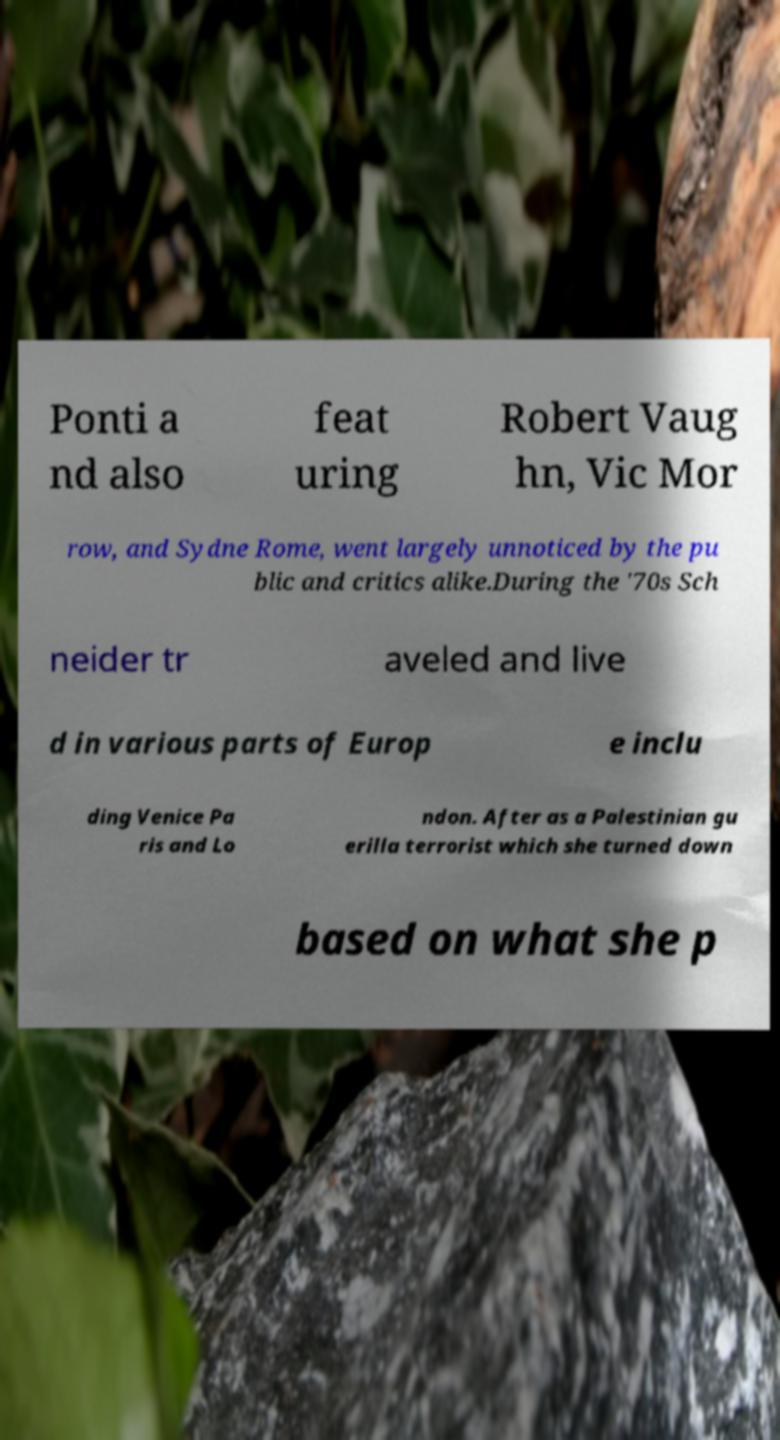What messages or text are displayed in this image? I need them in a readable, typed format. Ponti a nd also feat uring Robert Vaug hn, Vic Mor row, and Sydne Rome, went largely unnoticed by the pu blic and critics alike.During the '70s Sch neider tr aveled and live d in various parts of Europ e inclu ding Venice Pa ris and Lo ndon. After as a Palestinian gu erilla terrorist which she turned down based on what she p 